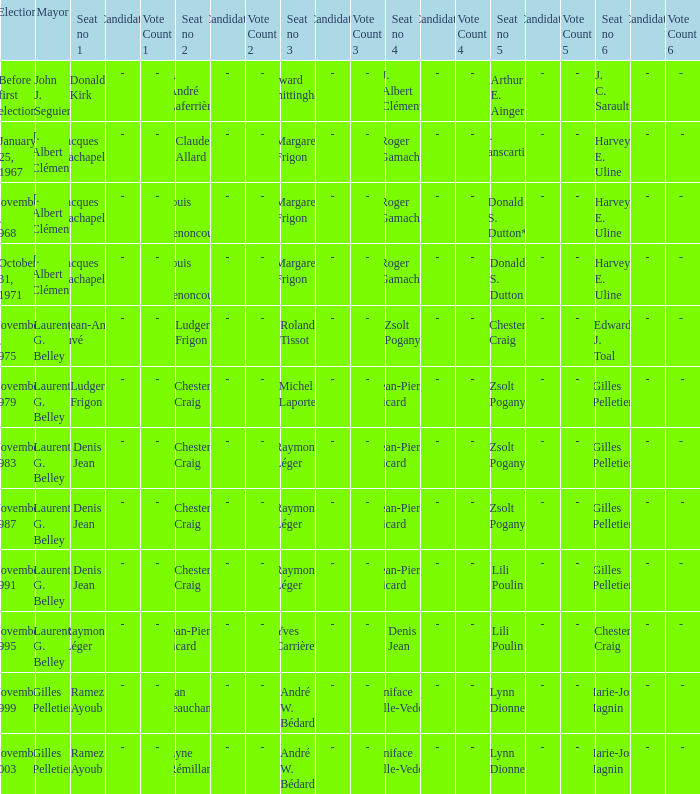When john j. seguier was the mayor, who occupied seat number 1? Donald Kirk. 